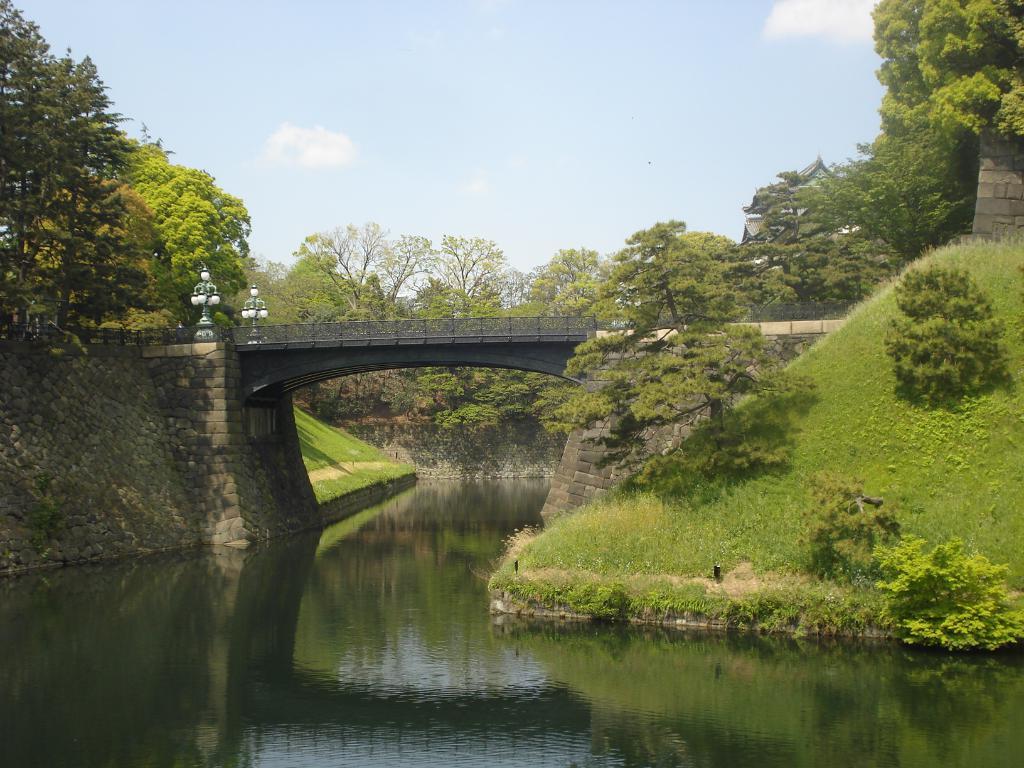Can you describe this image briefly? In this image I can see a bridge , under the bridge I can see the lake ,at the top I can see the sky , in the middle I can see trees and grass. 